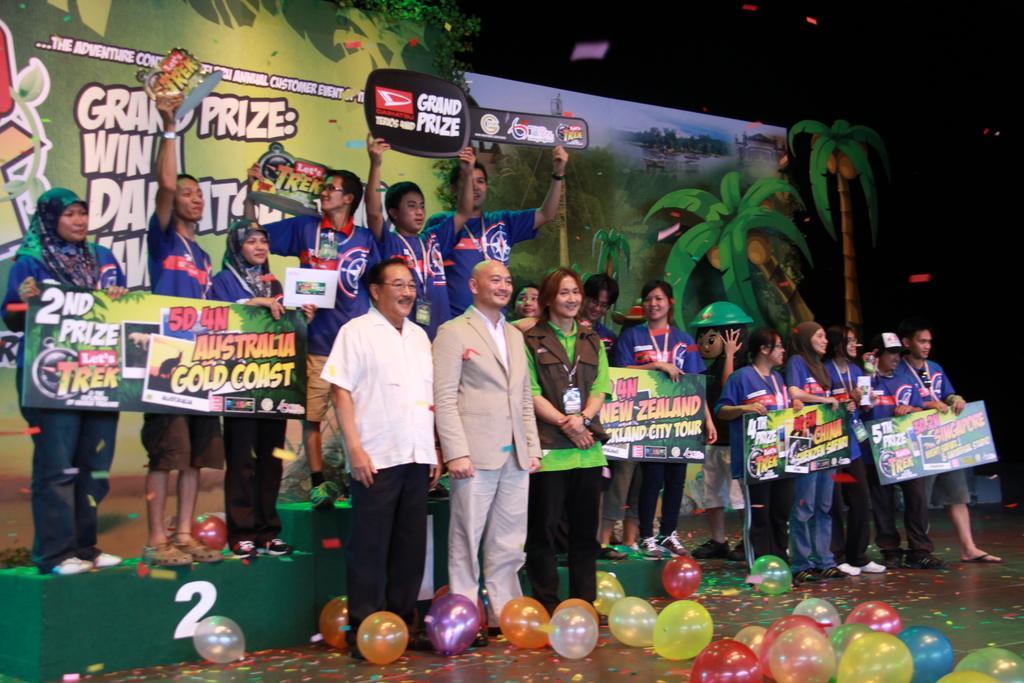In one or two sentences, can you explain what this image depicts? In this picture we can see some people standing, some of these people are holding boards, at the bottom there are some balloons, there is a dark background, on the left side we can see a hoarding, we can see depictions of trees on the hoarding. 